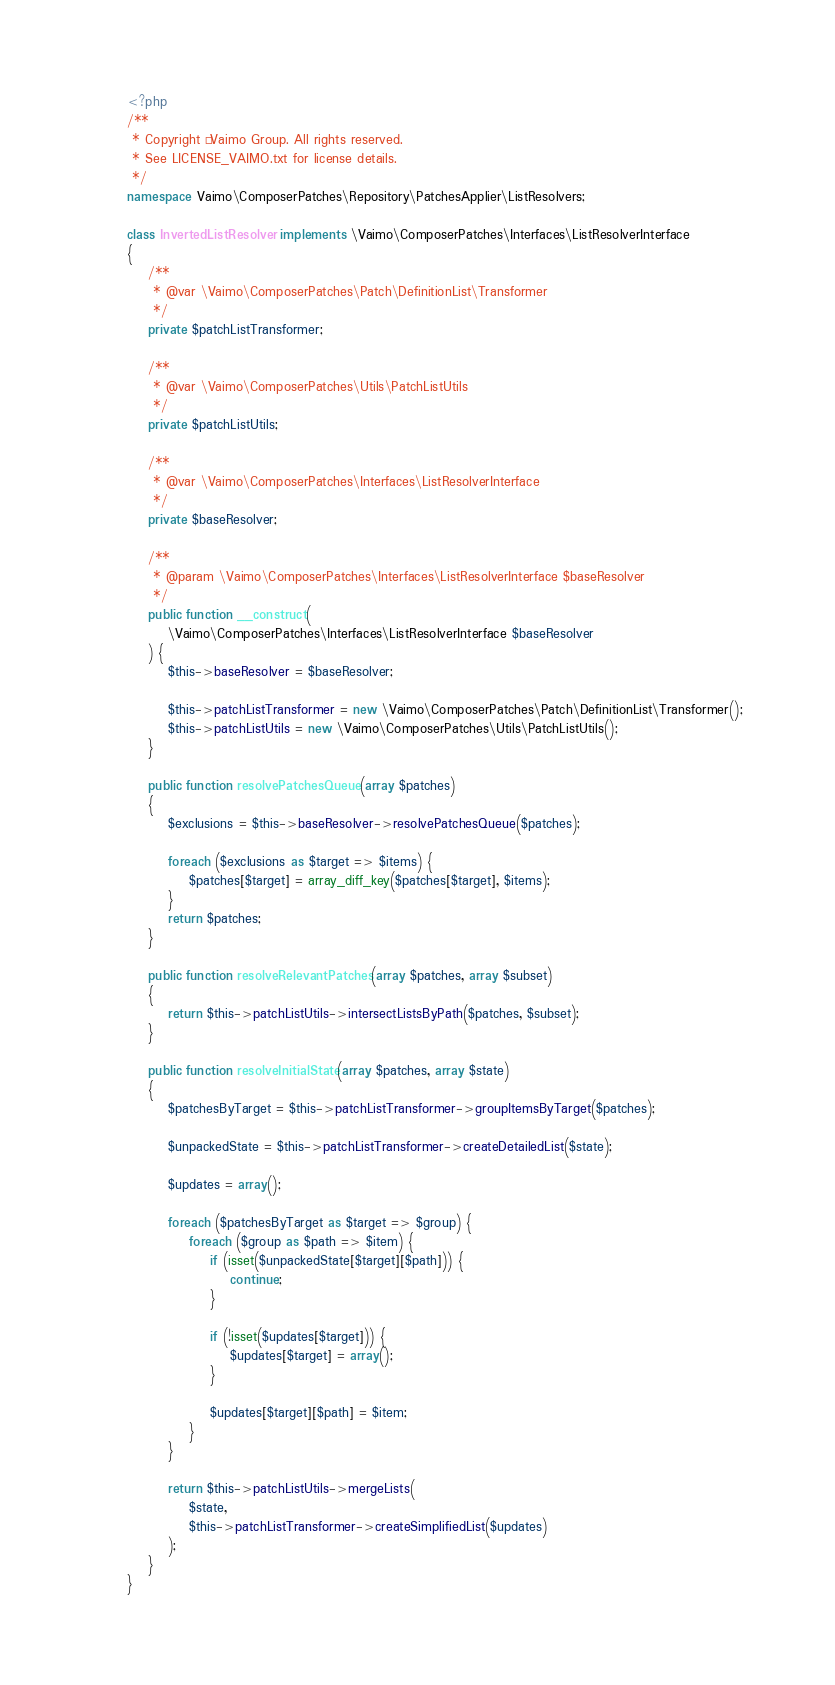Convert code to text. <code><loc_0><loc_0><loc_500><loc_500><_PHP_><?php
/**
 * Copyright © Vaimo Group. All rights reserved.
 * See LICENSE_VAIMO.txt for license details.
 */
namespace Vaimo\ComposerPatches\Repository\PatchesApplier\ListResolvers;

class InvertedListResolver implements \Vaimo\ComposerPatches\Interfaces\ListResolverInterface
{
    /**
     * @var \Vaimo\ComposerPatches\Patch\DefinitionList\Transformer
     */
    private $patchListTransformer;

    /**
     * @var \Vaimo\ComposerPatches\Utils\PatchListUtils
     */
    private $patchListUtils;

    /**
     * @var \Vaimo\ComposerPatches\Interfaces\ListResolverInterface
     */
    private $baseResolver;

    /**
     * @param \Vaimo\ComposerPatches\Interfaces\ListResolverInterface $baseResolver
     */
    public function __construct(
        \Vaimo\ComposerPatches\Interfaces\ListResolverInterface $baseResolver
    ) {
        $this->baseResolver = $baseResolver;

        $this->patchListTransformer = new \Vaimo\ComposerPatches\Patch\DefinitionList\Transformer();
        $this->patchListUtils = new \Vaimo\ComposerPatches\Utils\PatchListUtils();
    }

    public function resolvePatchesQueue(array $patches)
    {
        $exclusions = $this->baseResolver->resolvePatchesQueue($patches);

        foreach ($exclusions as $target => $items) {
            $patches[$target] = array_diff_key($patches[$target], $items);
        }
        return $patches;
    }

    public function resolveRelevantPatches(array $patches, array $subset)
    {
        return $this->patchListUtils->intersectListsByPath($patches, $subset);
    }

    public function resolveInitialState(array $patches, array $state)
    {
        $patchesByTarget = $this->patchListTransformer->groupItemsByTarget($patches);

        $unpackedState = $this->patchListTransformer->createDetailedList($state);

        $updates = array();

        foreach ($patchesByTarget as $target => $group) {
            foreach ($group as $path => $item) {
                if (isset($unpackedState[$target][$path])) {
                    continue;
                }

                if (!isset($updates[$target])) {
                    $updates[$target] = array();
                }

                $updates[$target][$path] = $item;
            }
        }

        return $this->patchListUtils->mergeLists(
            $state,
            $this->patchListTransformer->createSimplifiedList($updates)
        );
    }
}
</code> 